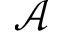Convert formula to latex. <formula><loc_0><loc_0><loc_500><loc_500>\mathcal { A }</formula> 